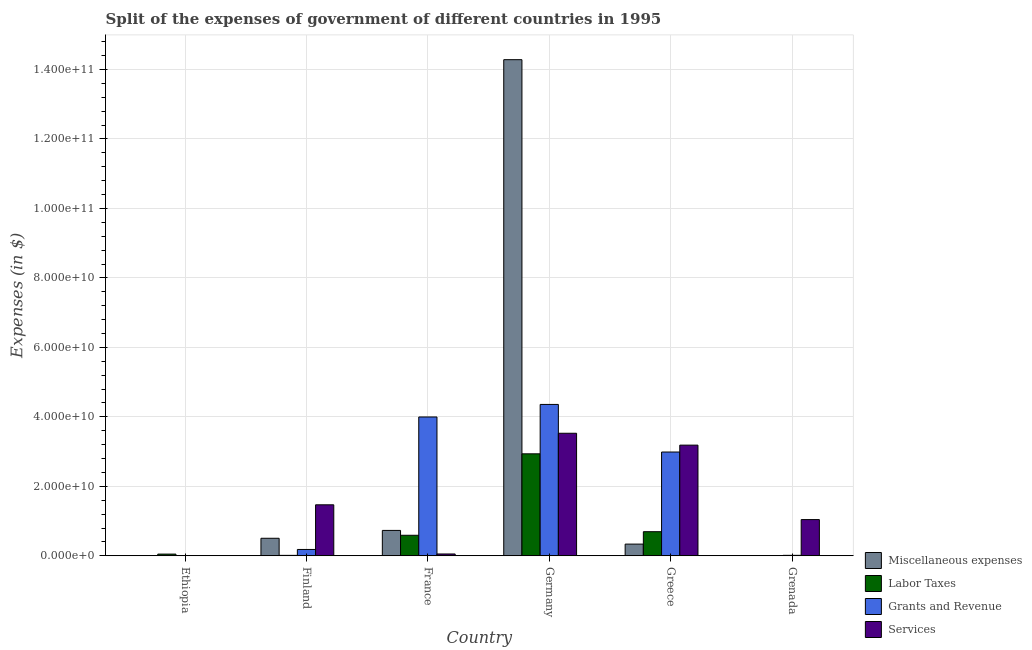Are the number of bars per tick equal to the number of legend labels?
Your response must be concise. Yes. Are the number of bars on each tick of the X-axis equal?
Your answer should be very brief. Yes. How many bars are there on the 5th tick from the right?
Keep it short and to the point. 4. What is the label of the 6th group of bars from the left?
Keep it short and to the point. Grenada. In how many cases, is the number of bars for a given country not equal to the number of legend labels?
Give a very brief answer. 0. What is the amount spent on grants and revenue in France?
Provide a short and direct response. 4.00e+1. Across all countries, what is the maximum amount spent on services?
Your response must be concise. 3.53e+1. Across all countries, what is the minimum amount spent on services?
Provide a succinct answer. 1.21e+07. In which country was the amount spent on grants and revenue maximum?
Ensure brevity in your answer.  Germany. In which country was the amount spent on grants and revenue minimum?
Provide a short and direct response. Ethiopia. What is the total amount spent on labor taxes in the graph?
Keep it short and to the point. 4.28e+1. What is the difference between the amount spent on services in Greece and that in Grenada?
Provide a succinct answer. 2.14e+1. What is the difference between the amount spent on grants and revenue in Germany and the amount spent on labor taxes in Ethiopia?
Make the answer very short. 4.31e+1. What is the average amount spent on grants and revenue per country?
Offer a very short reply. 1.92e+1. What is the difference between the amount spent on services and amount spent on grants and revenue in Grenada?
Provide a short and direct response. 1.03e+1. In how many countries, is the amount spent on miscellaneous expenses greater than 144000000000 $?
Provide a succinct answer. 0. What is the ratio of the amount spent on labor taxes in Finland to that in Grenada?
Your answer should be compact. 42.97. Is the amount spent on grants and revenue in Ethiopia less than that in Grenada?
Your answer should be very brief. Yes. Is the difference between the amount spent on labor taxes in France and Germany greater than the difference between the amount spent on grants and revenue in France and Germany?
Make the answer very short. No. What is the difference between the highest and the second highest amount spent on miscellaneous expenses?
Give a very brief answer. 1.36e+11. What is the difference between the highest and the lowest amount spent on services?
Your answer should be compact. 3.53e+1. Is the sum of the amount spent on miscellaneous expenses in Ethiopia and Greece greater than the maximum amount spent on labor taxes across all countries?
Ensure brevity in your answer.  No. What does the 4th bar from the left in France represents?
Your response must be concise. Services. What does the 4th bar from the right in France represents?
Offer a very short reply. Miscellaneous expenses. How many bars are there?
Provide a short and direct response. 24. How many countries are there in the graph?
Provide a succinct answer. 6. Are the values on the major ticks of Y-axis written in scientific E-notation?
Ensure brevity in your answer.  Yes. Does the graph contain any zero values?
Offer a terse response. No. Where does the legend appear in the graph?
Provide a succinct answer. Bottom right. How are the legend labels stacked?
Provide a succinct answer. Vertical. What is the title of the graph?
Ensure brevity in your answer.  Split of the expenses of government of different countries in 1995. What is the label or title of the X-axis?
Offer a very short reply. Country. What is the label or title of the Y-axis?
Keep it short and to the point. Expenses (in $). What is the Expenses (in $) of Miscellaneous expenses in Ethiopia?
Offer a very short reply. 2.18e+07. What is the Expenses (in $) in Labor Taxes in Ethiopia?
Your response must be concise. 4.86e+08. What is the Expenses (in $) of Grants and Revenue in Ethiopia?
Give a very brief answer. 1.34e+07. What is the Expenses (in $) in Services in Ethiopia?
Provide a short and direct response. 1.21e+07. What is the Expenses (in $) in Miscellaneous expenses in Finland?
Offer a terse response. 5.04e+09. What is the Expenses (in $) of Labor Taxes in Finland?
Your response must be concise. 1.22e+08. What is the Expenses (in $) in Grants and Revenue in Finland?
Offer a terse response. 1.82e+09. What is the Expenses (in $) in Services in Finland?
Your answer should be compact. 1.47e+1. What is the Expenses (in $) in Miscellaneous expenses in France?
Provide a short and direct response. 7.31e+09. What is the Expenses (in $) of Labor Taxes in France?
Make the answer very short. 5.91e+09. What is the Expenses (in $) in Grants and Revenue in France?
Your answer should be compact. 4.00e+1. What is the Expenses (in $) in Services in France?
Provide a short and direct response. 5.24e+08. What is the Expenses (in $) of Miscellaneous expenses in Germany?
Offer a terse response. 1.43e+11. What is the Expenses (in $) of Labor Taxes in Germany?
Your answer should be compact. 2.94e+1. What is the Expenses (in $) of Grants and Revenue in Germany?
Your response must be concise. 4.36e+1. What is the Expenses (in $) of Services in Germany?
Your answer should be compact. 3.53e+1. What is the Expenses (in $) of Miscellaneous expenses in Greece?
Your answer should be very brief. 3.37e+09. What is the Expenses (in $) in Labor Taxes in Greece?
Offer a terse response. 6.94e+09. What is the Expenses (in $) of Grants and Revenue in Greece?
Ensure brevity in your answer.  2.99e+1. What is the Expenses (in $) in Services in Greece?
Offer a very short reply. 3.19e+1. What is the Expenses (in $) in Miscellaneous expenses in Grenada?
Your response must be concise. 1.60e+06. What is the Expenses (in $) in Labor Taxes in Grenada?
Ensure brevity in your answer.  2.84e+06. What is the Expenses (in $) of Grants and Revenue in Grenada?
Keep it short and to the point. 1.30e+08. What is the Expenses (in $) of Services in Grenada?
Offer a very short reply. 1.04e+1. Across all countries, what is the maximum Expenses (in $) in Miscellaneous expenses?
Your response must be concise. 1.43e+11. Across all countries, what is the maximum Expenses (in $) of Labor Taxes?
Your response must be concise. 2.94e+1. Across all countries, what is the maximum Expenses (in $) of Grants and Revenue?
Your response must be concise. 4.36e+1. Across all countries, what is the maximum Expenses (in $) in Services?
Ensure brevity in your answer.  3.53e+1. Across all countries, what is the minimum Expenses (in $) in Miscellaneous expenses?
Your response must be concise. 1.60e+06. Across all countries, what is the minimum Expenses (in $) of Labor Taxes?
Your response must be concise. 2.84e+06. Across all countries, what is the minimum Expenses (in $) of Grants and Revenue?
Provide a short and direct response. 1.34e+07. Across all countries, what is the minimum Expenses (in $) of Services?
Provide a short and direct response. 1.21e+07. What is the total Expenses (in $) in Miscellaneous expenses in the graph?
Provide a succinct answer. 1.59e+11. What is the total Expenses (in $) in Labor Taxes in the graph?
Your answer should be compact. 4.28e+1. What is the total Expenses (in $) in Grants and Revenue in the graph?
Your response must be concise. 1.15e+11. What is the total Expenses (in $) of Services in the graph?
Give a very brief answer. 9.28e+1. What is the difference between the Expenses (in $) in Miscellaneous expenses in Ethiopia and that in Finland?
Make the answer very short. -5.02e+09. What is the difference between the Expenses (in $) of Labor Taxes in Ethiopia and that in Finland?
Provide a short and direct response. 3.64e+08. What is the difference between the Expenses (in $) in Grants and Revenue in Ethiopia and that in Finland?
Your answer should be very brief. -1.81e+09. What is the difference between the Expenses (in $) in Services in Ethiopia and that in Finland?
Give a very brief answer. -1.47e+1. What is the difference between the Expenses (in $) of Miscellaneous expenses in Ethiopia and that in France?
Ensure brevity in your answer.  -7.29e+09. What is the difference between the Expenses (in $) of Labor Taxes in Ethiopia and that in France?
Offer a terse response. -5.42e+09. What is the difference between the Expenses (in $) in Grants and Revenue in Ethiopia and that in France?
Provide a short and direct response. -4.00e+1. What is the difference between the Expenses (in $) in Services in Ethiopia and that in France?
Make the answer very short. -5.12e+08. What is the difference between the Expenses (in $) in Miscellaneous expenses in Ethiopia and that in Germany?
Your answer should be very brief. -1.43e+11. What is the difference between the Expenses (in $) in Labor Taxes in Ethiopia and that in Germany?
Offer a very short reply. -2.89e+1. What is the difference between the Expenses (in $) in Grants and Revenue in Ethiopia and that in Germany?
Your answer should be compact. -4.36e+1. What is the difference between the Expenses (in $) of Services in Ethiopia and that in Germany?
Offer a very short reply. -3.53e+1. What is the difference between the Expenses (in $) in Miscellaneous expenses in Ethiopia and that in Greece?
Ensure brevity in your answer.  -3.35e+09. What is the difference between the Expenses (in $) of Labor Taxes in Ethiopia and that in Greece?
Offer a terse response. -6.45e+09. What is the difference between the Expenses (in $) of Grants and Revenue in Ethiopia and that in Greece?
Keep it short and to the point. -2.99e+1. What is the difference between the Expenses (in $) in Services in Ethiopia and that in Greece?
Your answer should be very brief. -3.18e+1. What is the difference between the Expenses (in $) of Miscellaneous expenses in Ethiopia and that in Grenada?
Your answer should be very brief. 2.02e+07. What is the difference between the Expenses (in $) of Labor Taxes in Ethiopia and that in Grenada?
Provide a short and direct response. 4.83e+08. What is the difference between the Expenses (in $) in Grants and Revenue in Ethiopia and that in Grenada?
Make the answer very short. -1.17e+08. What is the difference between the Expenses (in $) in Services in Ethiopia and that in Grenada?
Provide a succinct answer. -1.04e+1. What is the difference between the Expenses (in $) in Miscellaneous expenses in Finland and that in France?
Offer a very short reply. -2.26e+09. What is the difference between the Expenses (in $) in Labor Taxes in Finland and that in France?
Make the answer very short. -5.79e+09. What is the difference between the Expenses (in $) in Grants and Revenue in Finland and that in France?
Provide a succinct answer. -3.81e+1. What is the difference between the Expenses (in $) in Services in Finland and that in France?
Offer a terse response. 1.42e+1. What is the difference between the Expenses (in $) of Miscellaneous expenses in Finland and that in Germany?
Keep it short and to the point. -1.38e+11. What is the difference between the Expenses (in $) of Labor Taxes in Finland and that in Germany?
Offer a very short reply. -2.92e+1. What is the difference between the Expenses (in $) in Grants and Revenue in Finland and that in Germany?
Your response must be concise. -4.18e+1. What is the difference between the Expenses (in $) of Services in Finland and that in Germany?
Your response must be concise. -2.06e+1. What is the difference between the Expenses (in $) in Miscellaneous expenses in Finland and that in Greece?
Offer a very short reply. 1.68e+09. What is the difference between the Expenses (in $) in Labor Taxes in Finland and that in Greece?
Your answer should be very brief. -6.81e+09. What is the difference between the Expenses (in $) in Grants and Revenue in Finland and that in Greece?
Ensure brevity in your answer.  -2.81e+1. What is the difference between the Expenses (in $) of Services in Finland and that in Greece?
Your answer should be very brief. -1.72e+1. What is the difference between the Expenses (in $) in Miscellaneous expenses in Finland and that in Grenada?
Give a very brief answer. 5.04e+09. What is the difference between the Expenses (in $) of Labor Taxes in Finland and that in Grenada?
Provide a succinct answer. 1.19e+08. What is the difference between the Expenses (in $) of Grants and Revenue in Finland and that in Grenada?
Give a very brief answer. 1.69e+09. What is the difference between the Expenses (in $) in Services in Finland and that in Grenada?
Your answer should be very brief. 4.25e+09. What is the difference between the Expenses (in $) in Miscellaneous expenses in France and that in Germany?
Offer a terse response. -1.36e+11. What is the difference between the Expenses (in $) in Labor Taxes in France and that in Germany?
Keep it short and to the point. -2.34e+1. What is the difference between the Expenses (in $) in Grants and Revenue in France and that in Germany?
Ensure brevity in your answer.  -3.61e+09. What is the difference between the Expenses (in $) of Services in France and that in Germany?
Your answer should be very brief. -3.48e+1. What is the difference between the Expenses (in $) in Miscellaneous expenses in France and that in Greece?
Your response must be concise. 3.94e+09. What is the difference between the Expenses (in $) in Labor Taxes in France and that in Greece?
Your answer should be very brief. -1.03e+09. What is the difference between the Expenses (in $) in Grants and Revenue in France and that in Greece?
Ensure brevity in your answer.  1.01e+1. What is the difference between the Expenses (in $) of Services in France and that in Greece?
Keep it short and to the point. -3.13e+1. What is the difference between the Expenses (in $) in Miscellaneous expenses in France and that in Grenada?
Make the answer very short. 7.31e+09. What is the difference between the Expenses (in $) in Labor Taxes in France and that in Grenada?
Your answer should be compact. 5.91e+09. What is the difference between the Expenses (in $) in Grants and Revenue in France and that in Grenada?
Provide a short and direct response. 3.98e+1. What is the difference between the Expenses (in $) in Services in France and that in Grenada?
Make the answer very short. -9.90e+09. What is the difference between the Expenses (in $) in Miscellaneous expenses in Germany and that in Greece?
Make the answer very short. 1.39e+11. What is the difference between the Expenses (in $) of Labor Taxes in Germany and that in Greece?
Your response must be concise. 2.24e+1. What is the difference between the Expenses (in $) of Grants and Revenue in Germany and that in Greece?
Make the answer very short. 1.37e+1. What is the difference between the Expenses (in $) of Services in Germany and that in Greece?
Give a very brief answer. 3.42e+09. What is the difference between the Expenses (in $) in Miscellaneous expenses in Germany and that in Grenada?
Give a very brief answer. 1.43e+11. What is the difference between the Expenses (in $) of Labor Taxes in Germany and that in Grenada?
Offer a very short reply. 2.94e+1. What is the difference between the Expenses (in $) of Grants and Revenue in Germany and that in Grenada?
Offer a terse response. 4.34e+1. What is the difference between the Expenses (in $) of Services in Germany and that in Grenada?
Your answer should be compact. 2.49e+1. What is the difference between the Expenses (in $) in Miscellaneous expenses in Greece and that in Grenada?
Make the answer very short. 3.37e+09. What is the difference between the Expenses (in $) of Labor Taxes in Greece and that in Grenada?
Your response must be concise. 6.93e+09. What is the difference between the Expenses (in $) of Grants and Revenue in Greece and that in Grenada?
Give a very brief answer. 2.97e+1. What is the difference between the Expenses (in $) in Services in Greece and that in Grenada?
Offer a terse response. 2.14e+1. What is the difference between the Expenses (in $) in Miscellaneous expenses in Ethiopia and the Expenses (in $) in Labor Taxes in Finland?
Make the answer very short. -1.00e+08. What is the difference between the Expenses (in $) of Miscellaneous expenses in Ethiopia and the Expenses (in $) of Grants and Revenue in Finland?
Provide a short and direct response. -1.80e+09. What is the difference between the Expenses (in $) of Miscellaneous expenses in Ethiopia and the Expenses (in $) of Services in Finland?
Your answer should be compact. -1.47e+1. What is the difference between the Expenses (in $) in Labor Taxes in Ethiopia and the Expenses (in $) in Grants and Revenue in Finland?
Give a very brief answer. -1.34e+09. What is the difference between the Expenses (in $) in Labor Taxes in Ethiopia and the Expenses (in $) in Services in Finland?
Your answer should be compact. -1.42e+1. What is the difference between the Expenses (in $) of Grants and Revenue in Ethiopia and the Expenses (in $) of Services in Finland?
Your response must be concise. -1.47e+1. What is the difference between the Expenses (in $) of Miscellaneous expenses in Ethiopia and the Expenses (in $) of Labor Taxes in France?
Ensure brevity in your answer.  -5.89e+09. What is the difference between the Expenses (in $) of Miscellaneous expenses in Ethiopia and the Expenses (in $) of Grants and Revenue in France?
Your response must be concise. -3.99e+1. What is the difference between the Expenses (in $) of Miscellaneous expenses in Ethiopia and the Expenses (in $) of Services in France?
Your answer should be compact. -5.02e+08. What is the difference between the Expenses (in $) in Labor Taxes in Ethiopia and the Expenses (in $) in Grants and Revenue in France?
Offer a terse response. -3.95e+1. What is the difference between the Expenses (in $) of Labor Taxes in Ethiopia and the Expenses (in $) of Services in France?
Your answer should be compact. -3.78e+07. What is the difference between the Expenses (in $) in Grants and Revenue in Ethiopia and the Expenses (in $) in Services in France?
Your answer should be compact. -5.11e+08. What is the difference between the Expenses (in $) of Miscellaneous expenses in Ethiopia and the Expenses (in $) of Labor Taxes in Germany?
Ensure brevity in your answer.  -2.93e+1. What is the difference between the Expenses (in $) of Miscellaneous expenses in Ethiopia and the Expenses (in $) of Grants and Revenue in Germany?
Your answer should be compact. -4.36e+1. What is the difference between the Expenses (in $) of Miscellaneous expenses in Ethiopia and the Expenses (in $) of Services in Germany?
Your response must be concise. -3.53e+1. What is the difference between the Expenses (in $) of Labor Taxes in Ethiopia and the Expenses (in $) of Grants and Revenue in Germany?
Provide a succinct answer. -4.31e+1. What is the difference between the Expenses (in $) of Labor Taxes in Ethiopia and the Expenses (in $) of Services in Germany?
Your response must be concise. -3.48e+1. What is the difference between the Expenses (in $) of Grants and Revenue in Ethiopia and the Expenses (in $) of Services in Germany?
Provide a short and direct response. -3.53e+1. What is the difference between the Expenses (in $) in Miscellaneous expenses in Ethiopia and the Expenses (in $) in Labor Taxes in Greece?
Give a very brief answer. -6.91e+09. What is the difference between the Expenses (in $) of Miscellaneous expenses in Ethiopia and the Expenses (in $) of Grants and Revenue in Greece?
Provide a short and direct response. -2.99e+1. What is the difference between the Expenses (in $) of Miscellaneous expenses in Ethiopia and the Expenses (in $) of Services in Greece?
Keep it short and to the point. -3.18e+1. What is the difference between the Expenses (in $) in Labor Taxes in Ethiopia and the Expenses (in $) in Grants and Revenue in Greece?
Provide a succinct answer. -2.94e+1. What is the difference between the Expenses (in $) of Labor Taxes in Ethiopia and the Expenses (in $) of Services in Greece?
Your response must be concise. -3.14e+1. What is the difference between the Expenses (in $) of Grants and Revenue in Ethiopia and the Expenses (in $) of Services in Greece?
Provide a succinct answer. -3.18e+1. What is the difference between the Expenses (in $) of Miscellaneous expenses in Ethiopia and the Expenses (in $) of Labor Taxes in Grenada?
Provide a short and direct response. 1.90e+07. What is the difference between the Expenses (in $) of Miscellaneous expenses in Ethiopia and the Expenses (in $) of Grants and Revenue in Grenada?
Your answer should be compact. -1.08e+08. What is the difference between the Expenses (in $) of Miscellaneous expenses in Ethiopia and the Expenses (in $) of Services in Grenada?
Your answer should be very brief. -1.04e+1. What is the difference between the Expenses (in $) of Labor Taxes in Ethiopia and the Expenses (in $) of Grants and Revenue in Grenada?
Give a very brief answer. 3.56e+08. What is the difference between the Expenses (in $) in Labor Taxes in Ethiopia and the Expenses (in $) in Services in Grenada?
Give a very brief answer. -9.94e+09. What is the difference between the Expenses (in $) in Grants and Revenue in Ethiopia and the Expenses (in $) in Services in Grenada?
Ensure brevity in your answer.  -1.04e+1. What is the difference between the Expenses (in $) in Miscellaneous expenses in Finland and the Expenses (in $) in Labor Taxes in France?
Provide a short and direct response. -8.64e+08. What is the difference between the Expenses (in $) in Miscellaneous expenses in Finland and the Expenses (in $) in Grants and Revenue in France?
Give a very brief answer. -3.49e+1. What is the difference between the Expenses (in $) in Miscellaneous expenses in Finland and the Expenses (in $) in Services in France?
Your answer should be compact. 4.52e+09. What is the difference between the Expenses (in $) in Labor Taxes in Finland and the Expenses (in $) in Grants and Revenue in France?
Keep it short and to the point. -3.98e+1. What is the difference between the Expenses (in $) in Labor Taxes in Finland and the Expenses (in $) in Services in France?
Your answer should be compact. -4.02e+08. What is the difference between the Expenses (in $) in Grants and Revenue in Finland and the Expenses (in $) in Services in France?
Provide a succinct answer. 1.30e+09. What is the difference between the Expenses (in $) in Miscellaneous expenses in Finland and the Expenses (in $) in Labor Taxes in Germany?
Your response must be concise. -2.43e+1. What is the difference between the Expenses (in $) in Miscellaneous expenses in Finland and the Expenses (in $) in Grants and Revenue in Germany?
Offer a terse response. -3.85e+1. What is the difference between the Expenses (in $) of Miscellaneous expenses in Finland and the Expenses (in $) of Services in Germany?
Offer a terse response. -3.02e+1. What is the difference between the Expenses (in $) of Labor Taxes in Finland and the Expenses (in $) of Grants and Revenue in Germany?
Your answer should be compact. -4.35e+1. What is the difference between the Expenses (in $) in Labor Taxes in Finland and the Expenses (in $) in Services in Germany?
Offer a terse response. -3.52e+1. What is the difference between the Expenses (in $) in Grants and Revenue in Finland and the Expenses (in $) in Services in Germany?
Give a very brief answer. -3.35e+1. What is the difference between the Expenses (in $) of Miscellaneous expenses in Finland and the Expenses (in $) of Labor Taxes in Greece?
Ensure brevity in your answer.  -1.89e+09. What is the difference between the Expenses (in $) of Miscellaneous expenses in Finland and the Expenses (in $) of Grants and Revenue in Greece?
Provide a succinct answer. -2.48e+1. What is the difference between the Expenses (in $) of Miscellaneous expenses in Finland and the Expenses (in $) of Services in Greece?
Your response must be concise. -2.68e+1. What is the difference between the Expenses (in $) in Labor Taxes in Finland and the Expenses (in $) in Grants and Revenue in Greece?
Provide a short and direct response. -2.98e+1. What is the difference between the Expenses (in $) of Labor Taxes in Finland and the Expenses (in $) of Services in Greece?
Keep it short and to the point. -3.17e+1. What is the difference between the Expenses (in $) in Grants and Revenue in Finland and the Expenses (in $) in Services in Greece?
Provide a short and direct response. -3.00e+1. What is the difference between the Expenses (in $) of Miscellaneous expenses in Finland and the Expenses (in $) of Labor Taxes in Grenada?
Your answer should be very brief. 5.04e+09. What is the difference between the Expenses (in $) of Miscellaneous expenses in Finland and the Expenses (in $) of Grants and Revenue in Grenada?
Your answer should be compact. 4.91e+09. What is the difference between the Expenses (in $) of Miscellaneous expenses in Finland and the Expenses (in $) of Services in Grenada?
Keep it short and to the point. -5.38e+09. What is the difference between the Expenses (in $) in Labor Taxes in Finland and the Expenses (in $) in Grants and Revenue in Grenada?
Ensure brevity in your answer.  -8.07e+06. What is the difference between the Expenses (in $) of Labor Taxes in Finland and the Expenses (in $) of Services in Grenada?
Your answer should be very brief. -1.03e+1. What is the difference between the Expenses (in $) in Grants and Revenue in Finland and the Expenses (in $) in Services in Grenada?
Provide a short and direct response. -8.60e+09. What is the difference between the Expenses (in $) in Miscellaneous expenses in France and the Expenses (in $) in Labor Taxes in Germany?
Offer a very short reply. -2.20e+1. What is the difference between the Expenses (in $) of Miscellaneous expenses in France and the Expenses (in $) of Grants and Revenue in Germany?
Offer a very short reply. -3.63e+1. What is the difference between the Expenses (in $) of Miscellaneous expenses in France and the Expenses (in $) of Services in Germany?
Provide a succinct answer. -2.80e+1. What is the difference between the Expenses (in $) in Labor Taxes in France and the Expenses (in $) in Grants and Revenue in Germany?
Make the answer very short. -3.77e+1. What is the difference between the Expenses (in $) in Labor Taxes in France and the Expenses (in $) in Services in Germany?
Provide a succinct answer. -2.94e+1. What is the difference between the Expenses (in $) of Grants and Revenue in France and the Expenses (in $) of Services in Germany?
Give a very brief answer. 4.69e+09. What is the difference between the Expenses (in $) of Miscellaneous expenses in France and the Expenses (in $) of Labor Taxes in Greece?
Offer a terse response. 3.72e+08. What is the difference between the Expenses (in $) in Miscellaneous expenses in France and the Expenses (in $) in Grants and Revenue in Greece?
Ensure brevity in your answer.  -2.26e+1. What is the difference between the Expenses (in $) in Miscellaneous expenses in France and the Expenses (in $) in Services in Greece?
Provide a succinct answer. -2.45e+1. What is the difference between the Expenses (in $) in Labor Taxes in France and the Expenses (in $) in Grants and Revenue in Greece?
Make the answer very short. -2.40e+1. What is the difference between the Expenses (in $) in Labor Taxes in France and the Expenses (in $) in Services in Greece?
Offer a very short reply. -2.59e+1. What is the difference between the Expenses (in $) in Grants and Revenue in France and the Expenses (in $) in Services in Greece?
Provide a short and direct response. 8.11e+09. What is the difference between the Expenses (in $) in Miscellaneous expenses in France and the Expenses (in $) in Labor Taxes in Grenada?
Provide a succinct answer. 7.31e+09. What is the difference between the Expenses (in $) of Miscellaneous expenses in France and the Expenses (in $) of Grants and Revenue in Grenada?
Your answer should be very brief. 7.18e+09. What is the difference between the Expenses (in $) in Miscellaneous expenses in France and the Expenses (in $) in Services in Grenada?
Give a very brief answer. -3.12e+09. What is the difference between the Expenses (in $) of Labor Taxes in France and the Expenses (in $) of Grants and Revenue in Grenada?
Ensure brevity in your answer.  5.78e+09. What is the difference between the Expenses (in $) in Labor Taxes in France and the Expenses (in $) in Services in Grenada?
Provide a short and direct response. -4.51e+09. What is the difference between the Expenses (in $) of Grants and Revenue in France and the Expenses (in $) of Services in Grenada?
Offer a very short reply. 2.95e+1. What is the difference between the Expenses (in $) in Miscellaneous expenses in Germany and the Expenses (in $) in Labor Taxes in Greece?
Give a very brief answer. 1.36e+11. What is the difference between the Expenses (in $) of Miscellaneous expenses in Germany and the Expenses (in $) of Grants and Revenue in Greece?
Offer a terse response. 1.13e+11. What is the difference between the Expenses (in $) of Miscellaneous expenses in Germany and the Expenses (in $) of Services in Greece?
Ensure brevity in your answer.  1.11e+11. What is the difference between the Expenses (in $) of Labor Taxes in Germany and the Expenses (in $) of Grants and Revenue in Greece?
Offer a terse response. -5.17e+08. What is the difference between the Expenses (in $) in Labor Taxes in Germany and the Expenses (in $) in Services in Greece?
Offer a terse response. -2.50e+09. What is the difference between the Expenses (in $) of Grants and Revenue in Germany and the Expenses (in $) of Services in Greece?
Your answer should be very brief. 1.17e+1. What is the difference between the Expenses (in $) in Miscellaneous expenses in Germany and the Expenses (in $) in Labor Taxes in Grenada?
Your response must be concise. 1.43e+11. What is the difference between the Expenses (in $) in Miscellaneous expenses in Germany and the Expenses (in $) in Grants and Revenue in Grenada?
Give a very brief answer. 1.43e+11. What is the difference between the Expenses (in $) in Miscellaneous expenses in Germany and the Expenses (in $) in Services in Grenada?
Offer a very short reply. 1.32e+11. What is the difference between the Expenses (in $) of Labor Taxes in Germany and the Expenses (in $) of Grants and Revenue in Grenada?
Keep it short and to the point. 2.92e+1. What is the difference between the Expenses (in $) in Labor Taxes in Germany and the Expenses (in $) in Services in Grenada?
Provide a short and direct response. 1.89e+1. What is the difference between the Expenses (in $) in Grants and Revenue in Germany and the Expenses (in $) in Services in Grenada?
Ensure brevity in your answer.  3.32e+1. What is the difference between the Expenses (in $) of Miscellaneous expenses in Greece and the Expenses (in $) of Labor Taxes in Grenada?
Provide a short and direct response. 3.37e+09. What is the difference between the Expenses (in $) in Miscellaneous expenses in Greece and the Expenses (in $) in Grants and Revenue in Grenada?
Provide a succinct answer. 3.24e+09. What is the difference between the Expenses (in $) in Miscellaneous expenses in Greece and the Expenses (in $) in Services in Grenada?
Offer a very short reply. -7.06e+09. What is the difference between the Expenses (in $) of Labor Taxes in Greece and the Expenses (in $) of Grants and Revenue in Grenada?
Your answer should be very brief. 6.81e+09. What is the difference between the Expenses (in $) in Labor Taxes in Greece and the Expenses (in $) in Services in Grenada?
Offer a very short reply. -3.49e+09. What is the difference between the Expenses (in $) of Grants and Revenue in Greece and the Expenses (in $) of Services in Grenada?
Offer a terse response. 1.95e+1. What is the average Expenses (in $) of Miscellaneous expenses per country?
Provide a succinct answer. 2.64e+1. What is the average Expenses (in $) of Labor Taxes per country?
Keep it short and to the point. 7.14e+09. What is the average Expenses (in $) of Grants and Revenue per country?
Give a very brief answer. 1.92e+1. What is the average Expenses (in $) of Services per country?
Your answer should be very brief. 1.55e+1. What is the difference between the Expenses (in $) in Miscellaneous expenses and Expenses (in $) in Labor Taxes in Ethiopia?
Keep it short and to the point. -4.64e+08. What is the difference between the Expenses (in $) of Miscellaneous expenses and Expenses (in $) of Grants and Revenue in Ethiopia?
Make the answer very short. 8.38e+06. What is the difference between the Expenses (in $) in Miscellaneous expenses and Expenses (in $) in Services in Ethiopia?
Make the answer very short. 9.73e+06. What is the difference between the Expenses (in $) of Labor Taxes and Expenses (in $) of Grants and Revenue in Ethiopia?
Give a very brief answer. 4.73e+08. What is the difference between the Expenses (in $) in Labor Taxes and Expenses (in $) in Services in Ethiopia?
Ensure brevity in your answer.  4.74e+08. What is the difference between the Expenses (in $) of Grants and Revenue and Expenses (in $) of Services in Ethiopia?
Offer a terse response. 1.35e+06. What is the difference between the Expenses (in $) of Miscellaneous expenses and Expenses (in $) of Labor Taxes in Finland?
Ensure brevity in your answer.  4.92e+09. What is the difference between the Expenses (in $) in Miscellaneous expenses and Expenses (in $) in Grants and Revenue in Finland?
Your answer should be very brief. 3.22e+09. What is the difference between the Expenses (in $) in Miscellaneous expenses and Expenses (in $) in Services in Finland?
Your response must be concise. -9.63e+09. What is the difference between the Expenses (in $) in Labor Taxes and Expenses (in $) in Grants and Revenue in Finland?
Make the answer very short. -1.70e+09. What is the difference between the Expenses (in $) in Labor Taxes and Expenses (in $) in Services in Finland?
Offer a terse response. -1.46e+1. What is the difference between the Expenses (in $) in Grants and Revenue and Expenses (in $) in Services in Finland?
Your answer should be compact. -1.29e+1. What is the difference between the Expenses (in $) of Miscellaneous expenses and Expenses (in $) of Labor Taxes in France?
Keep it short and to the point. 1.40e+09. What is the difference between the Expenses (in $) of Miscellaneous expenses and Expenses (in $) of Grants and Revenue in France?
Ensure brevity in your answer.  -3.27e+1. What is the difference between the Expenses (in $) in Miscellaneous expenses and Expenses (in $) in Services in France?
Keep it short and to the point. 6.78e+09. What is the difference between the Expenses (in $) in Labor Taxes and Expenses (in $) in Grants and Revenue in France?
Provide a short and direct response. -3.41e+1. What is the difference between the Expenses (in $) of Labor Taxes and Expenses (in $) of Services in France?
Provide a short and direct response. 5.38e+09. What is the difference between the Expenses (in $) of Grants and Revenue and Expenses (in $) of Services in France?
Provide a short and direct response. 3.94e+1. What is the difference between the Expenses (in $) in Miscellaneous expenses and Expenses (in $) in Labor Taxes in Germany?
Give a very brief answer. 1.13e+11. What is the difference between the Expenses (in $) in Miscellaneous expenses and Expenses (in $) in Grants and Revenue in Germany?
Offer a terse response. 9.93e+1. What is the difference between the Expenses (in $) in Miscellaneous expenses and Expenses (in $) in Services in Germany?
Keep it short and to the point. 1.08e+11. What is the difference between the Expenses (in $) in Labor Taxes and Expenses (in $) in Grants and Revenue in Germany?
Ensure brevity in your answer.  -1.42e+1. What is the difference between the Expenses (in $) of Labor Taxes and Expenses (in $) of Services in Germany?
Provide a succinct answer. -5.92e+09. What is the difference between the Expenses (in $) in Grants and Revenue and Expenses (in $) in Services in Germany?
Your answer should be very brief. 8.30e+09. What is the difference between the Expenses (in $) of Miscellaneous expenses and Expenses (in $) of Labor Taxes in Greece?
Your response must be concise. -3.57e+09. What is the difference between the Expenses (in $) in Miscellaneous expenses and Expenses (in $) in Grants and Revenue in Greece?
Your answer should be compact. -2.65e+1. What is the difference between the Expenses (in $) in Miscellaneous expenses and Expenses (in $) in Services in Greece?
Offer a terse response. -2.85e+1. What is the difference between the Expenses (in $) of Labor Taxes and Expenses (in $) of Grants and Revenue in Greece?
Provide a short and direct response. -2.29e+1. What is the difference between the Expenses (in $) of Labor Taxes and Expenses (in $) of Services in Greece?
Your response must be concise. -2.49e+1. What is the difference between the Expenses (in $) of Grants and Revenue and Expenses (in $) of Services in Greece?
Ensure brevity in your answer.  -1.98e+09. What is the difference between the Expenses (in $) in Miscellaneous expenses and Expenses (in $) in Labor Taxes in Grenada?
Provide a succinct answer. -1.24e+06. What is the difference between the Expenses (in $) of Miscellaneous expenses and Expenses (in $) of Grants and Revenue in Grenada?
Your response must be concise. -1.28e+08. What is the difference between the Expenses (in $) of Miscellaneous expenses and Expenses (in $) of Services in Grenada?
Ensure brevity in your answer.  -1.04e+1. What is the difference between the Expenses (in $) in Labor Taxes and Expenses (in $) in Grants and Revenue in Grenada?
Offer a very short reply. -1.27e+08. What is the difference between the Expenses (in $) in Labor Taxes and Expenses (in $) in Services in Grenada?
Provide a succinct answer. -1.04e+1. What is the difference between the Expenses (in $) in Grants and Revenue and Expenses (in $) in Services in Grenada?
Your answer should be very brief. -1.03e+1. What is the ratio of the Expenses (in $) in Miscellaneous expenses in Ethiopia to that in Finland?
Your answer should be very brief. 0. What is the ratio of the Expenses (in $) of Labor Taxes in Ethiopia to that in Finland?
Keep it short and to the point. 3.98. What is the ratio of the Expenses (in $) of Grants and Revenue in Ethiopia to that in Finland?
Offer a terse response. 0.01. What is the ratio of the Expenses (in $) in Services in Ethiopia to that in Finland?
Your response must be concise. 0. What is the ratio of the Expenses (in $) of Miscellaneous expenses in Ethiopia to that in France?
Offer a terse response. 0. What is the ratio of the Expenses (in $) of Labor Taxes in Ethiopia to that in France?
Ensure brevity in your answer.  0.08. What is the ratio of the Expenses (in $) in Grants and Revenue in Ethiopia to that in France?
Give a very brief answer. 0. What is the ratio of the Expenses (in $) of Services in Ethiopia to that in France?
Ensure brevity in your answer.  0.02. What is the ratio of the Expenses (in $) in Miscellaneous expenses in Ethiopia to that in Germany?
Your answer should be very brief. 0. What is the ratio of the Expenses (in $) of Labor Taxes in Ethiopia to that in Germany?
Provide a succinct answer. 0.02. What is the ratio of the Expenses (in $) of Grants and Revenue in Ethiopia to that in Germany?
Keep it short and to the point. 0. What is the ratio of the Expenses (in $) of Services in Ethiopia to that in Germany?
Ensure brevity in your answer.  0. What is the ratio of the Expenses (in $) in Miscellaneous expenses in Ethiopia to that in Greece?
Your response must be concise. 0.01. What is the ratio of the Expenses (in $) of Labor Taxes in Ethiopia to that in Greece?
Your answer should be compact. 0.07. What is the ratio of the Expenses (in $) of Services in Ethiopia to that in Greece?
Ensure brevity in your answer.  0. What is the ratio of the Expenses (in $) of Miscellaneous expenses in Ethiopia to that in Grenada?
Ensure brevity in your answer.  13.62. What is the ratio of the Expenses (in $) in Labor Taxes in Ethiopia to that in Grenada?
Make the answer very short. 171.19. What is the ratio of the Expenses (in $) of Grants and Revenue in Ethiopia to that in Grenada?
Ensure brevity in your answer.  0.1. What is the ratio of the Expenses (in $) in Services in Ethiopia to that in Grenada?
Offer a terse response. 0. What is the ratio of the Expenses (in $) of Miscellaneous expenses in Finland to that in France?
Offer a very short reply. 0.69. What is the ratio of the Expenses (in $) of Labor Taxes in Finland to that in France?
Offer a terse response. 0.02. What is the ratio of the Expenses (in $) in Grants and Revenue in Finland to that in France?
Ensure brevity in your answer.  0.05. What is the ratio of the Expenses (in $) in Services in Finland to that in France?
Ensure brevity in your answer.  28.01. What is the ratio of the Expenses (in $) in Miscellaneous expenses in Finland to that in Germany?
Your answer should be very brief. 0.04. What is the ratio of the Expenses (in $) of Labor Taxes in Finland to that in Germany?
Your answer should be compact. 0. What is the ratio of the Expenses (in $) in Grants and Revenue in Finland to that in Germany?
Keep it short and to the point. 0.04. What is the ratio of the Expenses (in $) of Services in Finland to that in Germany?
Offer a terse response. 0.42. What is the ratio of the Expenses (in $) of Miscellaneous expenses in Finland to that in Greece?
Your answer should be compact. 1.5. What is the ratio of the Expenses (in $) of Labor Taxes in Finland to that in Greece?
Provide a succinct answer. 0.02. What is the ratio of the Expenses (in $) in Grants and Revenue in Finland to that in Greece?
Offer a very short reply. 0.06. What is the ratio of the Expenses (in $) of Services in Finland to that in Greece?
Give a very brief answer. 0.46. What is the ratio of the Expenses (in $) of Miscellaneous expenses in Finland to that in Grenada?
Give a very brief answer. 3153.12. What is the ratio of the Expenses (in $) of Labor Taxes in Finland to that in Grenada?
Your answer should be very brief. 42.97. What is the ratio of the Expenses (in $) of Grants and Revenue in Finland to that in Grenada?
Keep it short and to the point. 14.02. What is the ratio of the Expenses (in $) of Services in Finland to that in Grenada?
Ensure brevity in your answer.  1.41. What is the ratio of the Expenses (in $) in Miscellaneous expenses in France to that in Germany?
Provide a succinct answer. 0.05. What is the ratio of the Expenses (in $) in Labor Taxes in France to that in Germany?
Offer a very short reply. 0.2. What is the ratio of the Expenses (in $) of Grants and Revenue in France to that in Germany?
Provide a short and direct response. 0.92. What is the ratio of the Expenses (in $) of Services in France to that in Germany?
Your answer should be very brief. 0.01. What is the ratio of the Expenses (in $) of Miscellaneous expenses in France to that in Greece?
Your answer should be very brief. 2.17. What is the ratio of the Expenses (in $) in Labor Taxes in France to that in Greece?
Offer a terse response. 0.85. What is the ratio of the Expenses (in $) in Grants and Revenue in France to that in Greece?
Provide a short and direct response. 1.34. What is the ratio of the Expenses (in $) of Services in France to that in Greece?
Offer a very short reply. 0.02. What is the ratio of the Expenses (in $) in Miscellaneous expenses in France to that in Grenada?
Give a very brief answer. 4567.5. What is the ratio of the Expenses (in $) in Labor Taxes in France to that in Grenada?
Offer a terse response. 2080.63. What is the ratio of the Expenses (in $) in Grants and Revenue in France to that in Grenada?
Make the answer very short. 307.18. What is the ratio of the Expenses (in $) of Services in France to that in Grenada?
Provide a succinct answer. 0.05. What is the ratio of the Expenses (in $) in Miscellaneous expenses in Germany to that in Greece?
Offer a terse response. 42.41. What is the ratio of the Expenses (in $) of Labor Taxes in Germany to that in Greece?
Offer a terse response. 4.23. What is the ratio of the Expenses (in $) in Grants and Revenue in Germany to that in Greece?
Provide a succinct answer. 1.46. What is the ratio of the Expenses (in $) in Services in Germany to that in Greece?
Provide a short and direct response. 1.11. What is the ratio of the Expenses (in $) of Miscellaneous expenses in Germany to that in Grenada?
Provide a short and direct response. 8.93e+04. What is the ratio of the Expenses (in $) in Labor Taxes in Germany to that in Grenada?
Keep it short and to the point. 1.03e+04. What is the ratio of the Expenses (in $) of Grants and Revenue in Germany to that in Grenada?
Provide a short and direct response. 334.95. What is the ratio of the Expenses (in $) of Services in Germany to that in Grenada?
Offer a terse response. 3.38. What is the ratio of the Expenses (in $) in Miscellaneous expenses in Greece to that in Grenada?
Your answer should be compact. 2105. What is the ratio of the Expenses (in $) in Labor Taxes in Greece to that in Grenada?
Provide a short and direct response. 2442.25. What is the ratio of the Expenses (in $) in Grants and Revenue in Greece to that in Grenada?
Your answer should be very brief. 229.62. What is the ratio of the Expenses (in $) of Services in Greece to that in Grenada?
Ensure brevity in your answer.  3.06. What is the difference between the highest and the second highest Expenses (in $) of Miscellaneous expenses?
Offer a very short reply. 1.36e+11. What is the difference between the highest and the second highest Expenses (in $) in Labor Taxes?
Offer a very short reply. 2.24e+1. What is the difference between the highest and the second highest Expenses (in $) in Grants and Revenue?
Provide a short and direct response. 3.61e+09. What is the difference between the highest and the second highest Expenses (in $) of Services?
Make the answer very short. 3.42e+09. What is the difference between the highest and the lowest Expenses (in $) of Miscellaneous expenses?
Offer a terse response. 1.43e+11. What is the difference between the highest and the lowest Expenses (in $) in Labor Taxes?
Provide a short and direct response. 2.94e+1. What is the difference between the highest and the lowest Expenses (in $) of Grants and Revenue?
Your answer should be very brief. 4.36e+1. What is the difference between the highest and the lowest Expenses (in $) of Services?
Make the answer very short. 3.53e+1. 